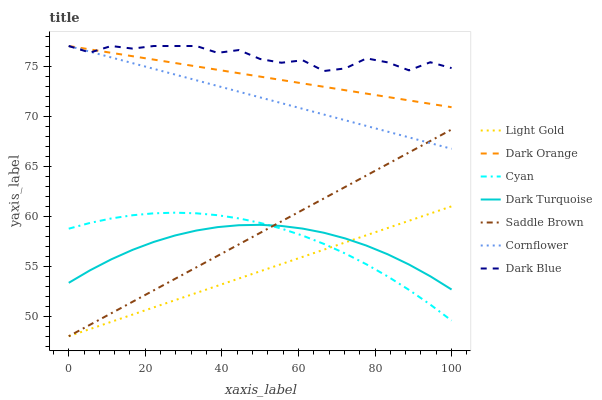Does Light Gold have the minimum area under the curve?
Answer yes or no. Yes. Does Dark Blue have the maximum area under the curve?
Answer yes or no. Yes. Does Cornflower have the minimum area under the curve?
Answer yes or no. No. Does Cornflower have the maximum area under the curve?
Answer yes or no. No. Is Cornflower the smoothest?
Answer yes or no. Yes. Is Dark Blue the roughest?
Answer yes or no. Yes. Is Dark Turquoise the smoothest?
Answer yes or no. No. Is Dark Turquoise the roughest?
Answer yes or no. No. Does Light Gold have the lowest value?
Answer yes or no. Yes. Does Cornflower have the lowest value?
Answer yes or no. No. Does Dark Blue have the highest value?
Answer yes or no. Yes. Does Dark Turquoise have the highest value?
Answer yes or no. No. Is Light Gold less than Dark Blue?
Answer yes or no. Yes. Is Dark Blue greater than Saddle Brown?
Answer yes or no. Yes. Does Dark Orange intersect Dark Blue?
Answer yes or no. Yes. Is Dark Orange less than Dark Blue?
Answer yes or no. No. Is Dark Orange greater than Dark Blue?
Answer yes or no. No. Does Light Gold intersect Dark Blue?
Answer yes or no. No. 